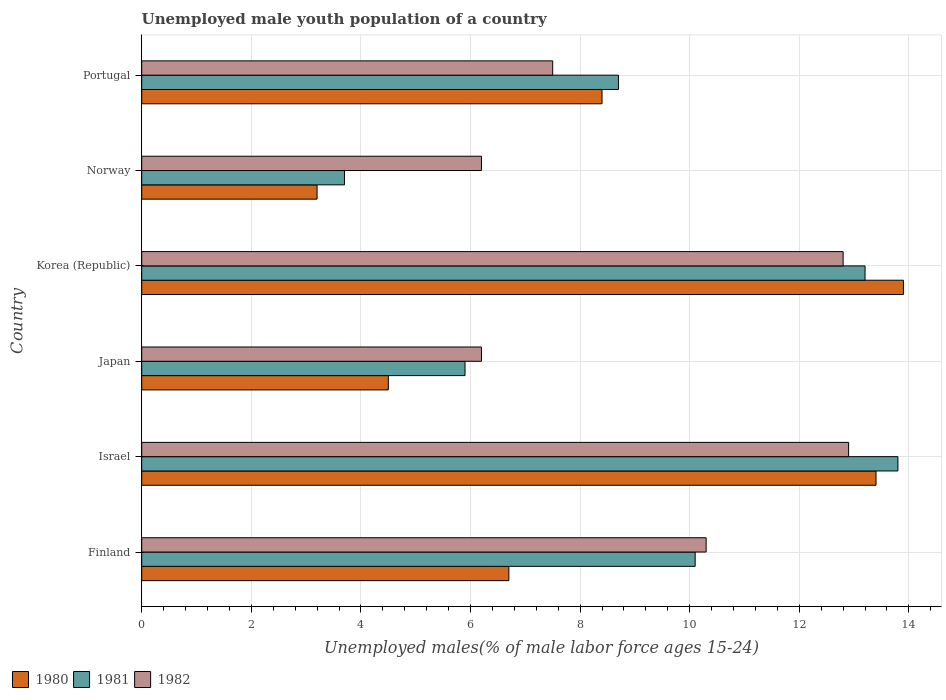How many different coloured bars are there?
Your answer should be compact. 3. How many groups of bars are there?
Offer a terse response. 6. Are the number of bars per tick equal to the number of legend labels?
Your answer should be very brief. Yes. Are the number of bars on each tick of the Y-axis equal?
Make the answer very short. Yes. How many bars are there on the 1st tick from the top?
Your response must be concise. 3. How many bars are there on the 1st tick from the bottom?
Offer a very short reply. 3. What is the label of the 4th group of bars from the top?
Provide a short and direct response. Japan. What is the percentage of unemployed male youth population in 1980 in Norway?
Offer a very short reply. 3.2. Across all countries, what is the maximum percentage of unemployed male youth population in 1980?
Provide a succinct answer. 13.9. Across all countries, what is the minimum percentage of unemployed male youth population in 1982?
Your answer should be compact. 6.2. In which country was the percentage of unemployed male youth population in 1980 minimum?
Your response must be concise. Norway. What is the total percentage of unemployed male youth population in 1981 in the graph?
Provide a short and direct response. 55.4. What is the difference between the percentage of unemployed male youth population in 1981 in Israel and that in Portugal?
Ensure brevity in your answer.  5.1. What is the difference between the percentage of unemployed male youth population in 1980 in Norway and the percentage of unemployed male youth population in 1981 in Portugal?
Keep it short and to the point. -5.5. What is the average percentage of unemployed male youth population in 1982 per country?
Ensure brevity in your answer.  9.32. What is the difference between the percentage of unemployed male youth population in 1980 and percentage of unemployed male youth population in 1981 in Korea (Republic)?
Offer a terse response. 0.7. What is the ratio of the percentage of unemployed male youth population in 1981 in Israel to that in Norway?
Keep it short and to the point. 3.73. Is the difference between the percentage of unemployed male youth population in 1980 in Israel and Norway greater than the difference between the percentage of unemployed male youth population in 1981 in Israel and Norway?
Give a very brief answer. Yes. What is the difference between the highest and the second highest percentage of unemployed male youth population in 1982?
Provide a short and direct response. 0.1. What is the difference between the highest and the lowest percentage of unemployed male youth population in 1982?
Your answer should be very brief. 6.7. In how many countries, is the percentage of unemployed male youth population in 1982 greater than the average percentage of unemployed male youth population in 1982 taken over all countries?
Your answer should be very brief. 3. Is the sum of the percentage of unemployed male youth population in 1982 in Finland and Portugal greater than the maximum percentage of unemployed male youth population in 1980 across all countries?
Provide a succinct answer. Yes. How many bars are there?
Make the answer very short. 18. How many countries are there in the graph?
Make the answer very short. 6. Are the values on the major ticks of X-axis written in scientific E-notation?
Ensure brevity in your answer.  No. Does the graph contain any zero values?
Keep it short and to the point. No. What is the title of the graph?
Give a very brief answer. Unemployed male youth population of a country. Does "1965" appear as one of the legend labels in the graph?
Keep it short and to the point. No. What is the label or title of the X-axis?
Give a very brief answer. Unemployed males(% of male labor force ages 15-24). What is the Unemployed males(% of male labor force ages 15-24) in 1980 in Finland?
Make the answer very short. 6.7. What is the Unemployed males(% of male labor force ages 15-24) of 1981 in Finland?
Provide a short and direct response. 10.1. What is the Unemployed males(% of male labor force ages 15-24) in 1982 in Finland?
Your answer should be compact. 10.3. What is the Unemployed males(% of male labor force ages 15-24) in 1980 in Israel?
Ensure brevity in your answer.  13.4. What is the Unemployed males(% of male labor force ages 15-24) in 1981 in Israel?
Give a very brief answer. 13.8. What is the Unemployed males(% of male labor force ages 15-24) of 1982 in Israel?
Offer a terse response. 12.9. What is the Unemployed males(% of male labor force ages 15-24) in 1980 in Japan?
Ensure brevity in your answer.  4.5. What is the Unemployed males(% of male labor force ages 15-24) of 1981 in Japan?
Keep it short and to the point. 5.9. What is the Unemployed males(% of male labor force ages 15-24) of 1982 in Japan?
Your answer should be very brief. 6.2. What is the Unemployed males(% of male labor force ages 15-24) in 1980 in Korea (Republic)?
Provide a succinct answer. 13.9. What is the Unemployed males(% of male labor force ages 15-24) in 1981 in Korea (Republic)?
Provide a short and direct response. 13.2. What is the Unemployed males(% of male labor force ages 15-24) of 1982 in Korea (Republic)?
Your answer should be compact. 12.8. What is the Unemployed males(% of male labor force ages 15-24) in 1980 in Norway?
Your response must be concise. 3.2. What is the Unemployed males(% of male labor force ages 15-24) in 1981 in Norway?
Your response must be concise. 3.7. What is the Unemployed males(% of male labor force ages 15-24) of 1982 in Norway?
Give a very brief answer. 6.2. What is the Unemployed males(% of male labor force ages 15-24) in 1980 in Portugal?
Provide a succinct answer. 8.4. What is the Unemployed males(% of male labor force ages 15-24) of 1981 in Portugal?
Offer a very short reply. 8.7. Across all countries, what is the maximum Unemployed males(% of male labor force ages 15-24) in 1980?
Your response must be concise. 13.9. Across all countries, what is the maximum Unemployed males(% of male labor force ages 15-24) in 1981?
Your answer should be compact. 13.8. Across all countries, what is the maximum Unemployed males(% of male labor force ages 15-24) in 1982?
Make the answer very short. 12.9. Across all countries, what is the minimum Unemployed males(% of male labor force ages 15-24) of 1980?
Offer a very short reply. 3.2. Across all countries, what is the minimum Unemployed males(% of male labor force ages 15-24) of 1981?
Offer a terse response. 3.7. Across all countries, what is the minimum Unemployed males(% of male labor force ages 15-24) of 1982?
Your response must be concise. 6.2. What is the total Unemployed males(% of male labor force ages 15-24) of 1980 in the graph?
Offer a terse response. 50.1. What is the total Unemployed males(% of male labor force ages 15-24) of 1981 in the graph?
Your response must be concise. 55.4. What is the total Unemployed males(% of male labor force ages 15-24) of 1982 in the graph?
Give a very brief answer. 55.9. What is the difference between the Unemployed males(% of male labor force ages 15-24) in 1981 in Finland and that in Israel?
Your answer should be compact. -3.7. What is the difference between the Unemployed males(% of male labor force ages 15-24) of 1981 in Finland and that in Japan?
Your answer should be very brief. 4.2. What is the difference between the Unemployed males(% of male labor force ages 15-24) in 1982 in Finland and that in Japan?
Your answer should be compact. 4.1. What is the difference between the Unemployed males(% of male labor force ages 15-24) in 1980 in Finland and that in Korea (Republic)?
Your response must be concise. -7.2. What is the difference between the Unemployed males(% of male labor force ages 15-24) of 1982 in Finland and that in Korea (Republic)?
Offer a terse response. -2.5. What is the difference between the Unemployed males(% of male labor force ages 15-24) in 1981 in Finland and that in Portugal?
Your response must be concise. 1.4. What is the difference between the Unemployed males(% of male labor force ages 15-24) in 1980 in Israel and that in Japan?
Provide a short and direct response. 8.9. What is the difference between the Unemployed males(% of male labor force ages 15-24) in 1982 in Israel and that in Japan?
Keep it short and to the point. 6.7. What is the difference between the Unemployed males(% of male labor force ages 15-24) of 1981 in Israel and that in Korea (Republic)?
Your answer should be very brief. 0.6. What is the difference between the Unemployed males(% of male labor force ages 15-24) in 1980 in Israel and that in Norway?
Offer a terse response. 10.2. What is the difference between the Unemployed males(% of male labor force ages 15-24) of 1981 in Israel and that in Portugal?
Make the answer very short. 5.1. What is the difference between the Unemployed males(% of male labor force ages 15-24) of 1980 in Japan and that in Korea (Republic)?
Your response must be concise. -9.4. What is the difference between the Unemployed males(% of male labor force ages 15-24) in 1981 in Japan and that in Korea (Republic)?
Offer a terse response. -7.3. What is the difference between the Unemployed males(% of male labor force ages 15-24) of 1982 in Japan and that in Korea (Republic)?
Provide a succinct answer. -6.6. What is the difference between the Unemployed males(% of male labor force ages 15-24) of 1980 in Japan and that in Norway?
Ensure brevity in your answer.  1.3. What is the difference between the Unemployed males(% of male labor force ages 15-24) in 1981 in Japan and that in Norway?
Provide a short and direct response. 2.2. What is the difference between the Unemployed males(% of male labor force ages 15-24) of 1980 in Japan and that in Portugal?
Offer a terse response. -3.9. What is the difference between the Unemployed males(% of male labor force ages 15-24) of 1982 in Japan and that in Portugal?
Your answer should be compact. -1.3. What is the difference between the Unemployed males(% of male labor force ages 15-24) in 1980 in Korea (Republic) and that in Norway?
Your answer should be very brief. 10.7. What is the difference between the Unemployed males(% of male labor force ages 15-24) in 1981 in Korea (Republic) and that in Norway?
Give a very brief answer. 9.5. What is the difference between the Unemployed males(% of male labor force ages 15-24) in 1982 in Korea (Republic) and that in Norway?
Give a very brief answer. 6.6. What is the difference between the Unemployed males(% of male labor force ages 15-24) of 1981 in Korea (Republic) and that in Portugal?
Offer a terse response. 4.5. What is the difference between the Unemployed males(% of male labor force ages 15-24) of 1980 in Norway and that in Portugal?
Give a very brief answer. -5.2. What is the difference between the Unemployed males(% of male labor force ages 15-24) in 1981 in Finland and the Unemployed males(% of male labor force ages 15-24) in 1982 in Israel?
Keep it short and to the point. -2.8. What is the difference between the Unemployed males(% of male labor force ages 15-24) in 1980 in Finland and the Unemployed males(% of male labor force ages 15-24) in 1981 in Japan?
Offer a very short reply. 0.8. What is the difference between the Unemployed males(% of male labor force ages 15-24) of 1980 in Finland and the Unemployed males(% of male labor force ages 15-24) of 1982 in Japan?
Provide a succinct answer. 0.5. What is the difference between the Unemployed males(% of male labor force ages 15-24) of 1980 in Finland and the Unemployed males(% of male labor force ages 15-24) of 1981 in Korea (Republic)?
Provide a succinct answer. -6.5. What is the difference between the Unemployed males(% of male labor force ages 15-24) in 1980 in Finland and the Unemployed males(% of male labor force ages 15-24) in 1982 in Korea (Republic)?
Provide a succinct answer. -6.1. What is the difference between the Unemployed males(% of male labor force ages 15-24) of 1981 in Finland and the Unemployed males(% of male labor force ages 15-24) of 1982 in Korea (Republic)?
Provide a succinct answer. -2.7. What is the difference between the Unemployed males(% of male labor force ages 15-24) in 1980 in Finland and the Unemployed males(% of male labor force ages 15-24) in 1981 in Norway?
Your response must be concise. 3. What is the difference between the Unemployed males(% of male labor force ages 15-24) in 1981 in Finland and the Unemployed males(% of male labor force ages 15-24) in 1982 in Portugal?
Offer a terse response. 2.6. What is the difference between the Unemployed males(% of male labor force ages 15-24) in 1980 in Israel and the Unemployed males(% of male labor force ages 15-24) in 1981 in Japan?
Your response must be concise. 7.5. What is the difference between the Unemployed males(% of male labor force ages 15-24) of 1980 in Israel and the Unemployed males(% of male labor force ages 15-24) of 1982 in Japan?
Offer a very short reply. 7.2. What is the difference between the Unemployed males(% of male labor force ages 15-24) of 1980 in Israel and the Unemployed males(% of male labor force ages 15-24) of 1981 in Korea (Republic)?
Provide a succinct answer. 0.2. What is the difference between the Unemployed males(% of male labor force ages 15-24) in 1981 in Israel and the Unemployed males(% of male labor force ages 15-24) in 1982 in Korea (Republic)?
Make the answer very short. 1. What is the difference between the Unemployed males(% of male labor force ages 15-24) in 1980 in Israel and the Unemployed males(% of male labor force ages 15-24) in 1981 in Norway?
Keep it short and to the point. 9.7. What is the difference between the Unemployed males(% of male labor force ages 15-24) of 1980 in Israel and the Unemployed males(% of male labor force ages 15-24) of 1981 in Portugal?
Offer a terse response. 4.7. What is the difference between the Unemployed males(% of male labor force ages 15-24) of 1980 in Israel and the Unemployed males(% of male labor force ages 15-24) of 1982 in Portugal?
Offer a terse response. 5.9. What is the difference between the Unemployed males(% of male labor force ages 15-24) of 1980 in Japan and the Unemployed males(% of male labor force ages 15-24) of 1982 in Korea (Republic)?
Your answer should be compact. -8.3. What is the difference between the Unemployed males(% of male labor force ages 15-24) in 1981 in Japan and the Unemployed males(% of male labor force ages 15-24) in 1982 in Korea (Republic)?
Keep it short and to the point. -6.9. What is the difference between the Unemployed males(% of male labor force ages 15-24) of 1981 in Japan and the Unemployed males(% of male labor force ages 15-24) of 1982 in Portugal?
Make the answer very short. -1.6. What is the difference between the Unemployed males(% of male labor force ages 15-24) in 1980 in Korea (Republic) and the Unemployed males(% of male labor force ages 15-24) in 1981 in Norway?
Give a very brief answer. 10.2. What is the difference between the Unemployed males(% of male labor force ages 15-24) in 1980 in Korea (Republic) and the Unemployed males(% of male labor force ages 15-24) in 1982 in Norway?
Keep it short and to the point. 7.7. What is the difference between the Unemployed males(% of male labor force ages 15-24) in 1980 in Korea (Republic) and the Unemployed males(% of male labor force ages 15-24) in 1981 in Portugal?
Ensure brevity in your answer.  5.2. What is the difference between the Unemployed males(% of male labor force ages 15-24) in 1980 in Korea (Republic) and the Unemployed males(% of male labor force ages 15-24) in 1982 in Portugal?
Provide a short and direct response. 6.4. What is the difference between the Unemployed males(% of male labor force ages 15-24) in 1980 in Norway and the Unemployed males(% of male labor force ages 15-24) in 1982 in Portugal?
Make the answer very short. -4.3. What is the difference between the Unemployed males(% of male labor force ages 15-24) in 1981 in Norway and the Unemployed males(% of male labor force ages 15-24) in 1982 in Portugal?
Ensure brevity in your answer.  -3.8. What is the average Unemployed males(% of male labor force ages 15-24) in 1980 per country?
Make the answer very short. 8.35. What is the average Unemployed males(% of male labor force ages 15-24) of 1981 per country?
Your answer should be compact. 9.23. What is the average Unemployed males(% of male labor force ages 15-24) of 1982 per country?
Offer a terse response. 9.32. What is the difference between the Unemployed males(% of male labor force ages 15-24) in 1981 and Unemployed males(% of male labor force ages 15-24) in 1982 in Finland?
Offer a terse response. -0.2. What is the difference between the Unemployed males(% of male labor force ages 15-24) of 1980 and Unemployed males(% of male labor force ages 15-24) of 1982 in Israel?
Provide a succinct answer. 0.5. What is the difference between the Unemployed males(% of male labor force ages 15-24) in 1981 and Unemployed males(% of male labor force ages 15-24) in 1982 in Israel?
Provide a succinct answer. 0.9. What is the difference between the Unemployed males(% of male labor force ages 15-24) of 1981 and Unemployed males(% of male labor force ages 15-24) of 1982 in Japan?
Provide a succinct answer. -0.3. What is the difference between the Unemployed males(% of male labor force ages 15-24) in 1980 and Unemployed males(% of male labor force ages 15-24) in 1982 in Korea (Republic)?
Your response must be concise. 1.1. What is the difference between the Unemployed males(% of male labor force ages 15-24) in 1980 and Unemployed males(% of male labor force ages 15-24) in 1982 in Norway?
Ensure brevity in your answer.  -3. What is the difference between the Unemployed males(% of male labor force ages 15-24) of 1981 and Unemployed males(% of male labor force ages 15-24) of 1982 in Norway?
Provide a short and direct response. -2.5. What is the difference between the Unemployed males(% of male labor force ages 15-24) of 1980 and Unemployed males(% of male labor force ages 15-24) of 1982 in Portugal?
Your answer should be very brief. 0.9. What is the ratio of the Unemployed males(% of male labor force ages 15-24) of 1981 in Finland to that in Israel?
Your answer should be very brief. 0.73. What is the ratio of the Unemployed males(% of male labor force ages 15-24) of 1982 in Finland to that in Israel?
Make the answer very short. 0.8. What is the ratio of the Unemployed males(% of male labor force ages 15-24) of 1980 in Finland to that in Japan?
Offer a very short reply. 1.49. What is the ratio of the Unemployed males(% of male labor force ages 15-24) in 1981 in Finland to that in Japan?
Your response must be concise. 1.71. What is the ratio of the Unemployed males(% of male labor force ages 15-24) of 1982 in Finland to that in Japan?
Ensure brevity in your answer.  1.66. What is the ratio of the Unemployed males(% of male labor force ages 15-24) of 1980 in Finland to that in Korea (Republic)?
Your answer should be very brief. 0.48. What is the ratio of the Unemployed males(% of male labor force ages 15-24) in 1981 in Finland to that in Korea (Republic)?
Offer a terse response. 0.77. What is the ratio of the Unemployed males(% of male labor force ages 15-24) in 1982 in Finland to that in Korea (Republic)?
Keep it short and to the point. 0.8. What is the ratio of the Unemployed males(% of male labor force ages 15-24) in 1980 in Finland to that in Norway?
Give a very brief answer. 2.09. What is the ratio of the Unemployed males(% of male labor force ages 15-24) of 1981 in Finland to that in Norway?
Provide a succinct answer. 2.73. What is the ratio of the Unemployed males(% of male labor force ages 15-24) of 1982 in Finland to that in Norway?
Your answer should be compact. 1.66. What is the ratio of the Unemployed males(% of male labor force ages 15-24) in 1980 in Finland to that in Portugal?
Keep it short and to the point. 0.8. What is the ratio of the Unemployed males(% of male labor force ages 15-24) of 1981 in Finland to that in Portugal?
Keep it short and to the point. 1.16. What is the ratio of the Unemployed males(% of male labor force ages 15-24) of 1982 in Finland to that in Portugal?
Provide a short and direct response. 1.37. What is the ratio of the Unemployed males(% of male labor force ages 15-24) of 1980 in Israel to that in Japan?
Offer a very short reply. 2.98. What is the ratio of the Unemployed males(% of male labor force ages 15-24) of 1981 in Israel to that in Japan?
Keep it short and to the point. 2.34. What is the ratio of the Unemployed males(% of male labor force ages 15-24) in 1982 in Israel to that in Japan?
Give a very brief answer. 2.08. What is the ratio of the Unemployed males(% of male labor force ages 15-24) of 1980 in Israel to that in Korea (Republic)?
Make the answer very short. 0.96. What is the ratio of the Unemployed males(% of male labor force ages 15-24) of 1981 in Israel to that in Korea (Republic)?
Your answer should be compact. 1.05. What is the ratio of the Unemployed males(% of male labor force ages 15-24) in 1982 in Israel to that in Korea (Republic)?
Give a very brief answer. 1.01. What is the ratio of the Unemployed males(% of male labor force ages 15-24) in 1980 in Israel to that in Norway?
Ensure brevity in your answer.  4.19. What is the ratio of the Unemployed males(% of male labor force ages 15-24) of 1981 in Israel to that in Norway?
Your answer should be very brief. 3.73. What is the ratio of the Unemployed males(% of male labor force ages 15-24) in 1982 in Israel to that in Norway?
Make the answer very short. 2.08. What is the ratio of the Unemployed males(% of male labor force ages 15-24) of 1980 in Israel to that in Portugal?
Your answer should be very brief. 1.6. What is the ratio of the Unemployed males(% of male labor force ages 15-24) in 1981 in Israel to that in Portugal?
Provide a short and direct response. 1.59. What is the ratio of the Unemployed males(% of male labor force ages 15-24) of 1982 in Israel to that in Portugal?
Provide a short and direct response. 1.72. What is the ratio of the Unemployed males(% of male labor force ages 15-24) in 1980 in Japan to that in Korea (Republic)?
Provide a succinct answer. 0.32. What is the ratio of the Unemployed males(% of male labor force ages 15-24) in 1981 in Japan to that in Korea (Republic)?
Your answer should be compact. 0.45. What is the ratio of the Unemployed males(% of male labor force ages 15-24) in 1982 in Japan to that in Korea (Republic)?
Your response must be concise. 0.48. What is the ratio of the Unemployed males(% of male labor force ages 15-24) in 1980 in Japan to that in Norway?
Keep it short and to the point. 1.41. What is the ratio of the Unemployed males(% of male labor force ages 15-24) of 1981 in Japan to that in Norway?
Keep it short and to the point. 1.59. What is the ratio of the Unemployed males(% of male labor force ages 15-24) of 1980 in Japan to that in Portugal?
Offer a terse response. 0.54. What is the ratio of the Unemployed males(% of male labor force ages 15-24) in 1981 in Japan to that in Portugal?
Make the answer very short. 0.68. What is the ratio of the Unemployed males(% of male labor force ages 15-24) in 1982 in Japan to that in Portugal?
Offer a terse response. 0.83. What is the ratio of the Unemployed males(% of male labor force ages 15-24) of 1980 in Korea (Republic) to that in Norway?
Offer a very short reply. 4.34. What is the ratio of the Unemployed males(% of male labor force ages 15-24) in 1981 in Korea (Republic) to that in Norway?
Ensure brevity in your answer.  3.57. What is the ratio of the Unemployed males(% of male labor force ages 15-24) of 1982 in Korea (Republic) to that in Norway?
Make the answer very short. 2.06. What is the ratio of the Unemployed males(% of male labor force ages 15-24) in 1980 in Korea (Republic) to that in Portugal?
Give a very brief answer. 1.65. What is the ratio of the Unemployed males(% of male labor force ages 15-24) of 1981 in Korea (Republic) to that in Portugal?
Offer a terse response. 1.52. What is the ratio of the Unemployed males(% of male labor force ages 15-24) in 1982 in Korea (Republic) to that in Portugal?
Offer a very short reply. 1.71. What is the ratio of the Unemployed males(% of male labor force ages 15-24) in 1980 in Norway to that in Portugal?
Your answer should be compact. 0.38. What is the ratio of the Unemployed males(% of male labor force ages 15-24) in 1981 in Norway to that in Portugal?
Keep it short and to the point. 0.43. What is the ratio of the Unemployed males(% of male labor force ages 15-24) of 1982 in Norway to that in Portugal?
Your response must be concise. 0.83. What is the difference between the highest and the second highest Unemployed males(% of male labor force ages 15-24) of 1980?
Your answer should be very brief. 0.5. What is the difference between the highest and the second highest Unemployed males(% of male labor force ages 15-24) of 1981?
Give a very brief answer. 0.6. What is the difference between the highest and the second highest Unemployed males(% of male labor force ages 15-24) of 1982?
Offer a very short reply. 0.1. What is the difference between the highest and the lowest Unemployed males(% of male labor force ages 15-24) of 1980?
Provide a succinct answer. 10.7. What is the difference between the highest and the lowest Unemployed males(% of male labor force ages 15-24) in 1981?
Provide a short and direct response. 10.1. What is the difference between the highest and the lowest Unemployed males(% of male labor force ages 15-24) of 1982?
Your answer should be very brief. 6.7. 